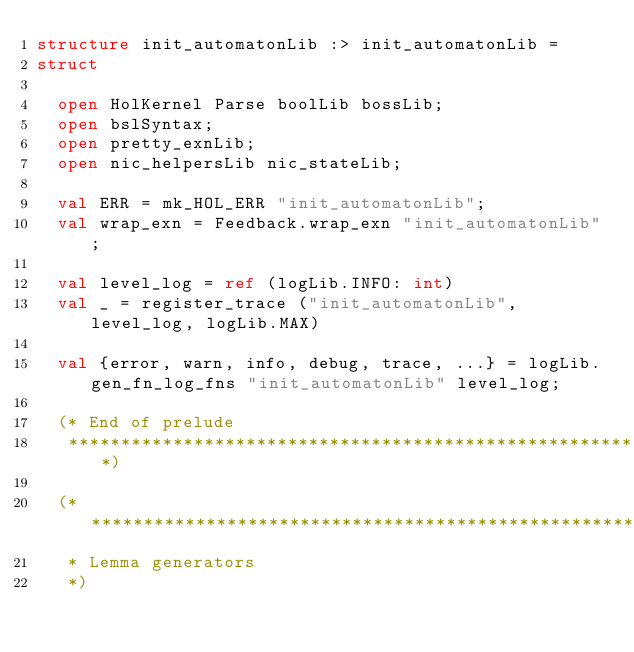Convert code to text. <code><loc_0><loc_0><loc_500><loc_500><_SML_>structure init_automatonLib :> init_automatonLib =
struct

  open HolKernel Parse boolLib bossLib;
  open bslSyntax;
  open pretty_exnLib;
  open nic_helpersLib nic_stateLib;

  val ERR = mk_HOL_ERR "init_automatonLib";
  val wrap_exn = Feedback.wrap_exn "init_automatonLib";

  val level_log = ref (logLib.INFO: int)
  val _ = register_trace ("init_automatonLib", level_log, logLib.MAX)

  val {error, warn, info, debug, trace, ...} = logLib.gen_fn_log_fns "init_automatonLib" level_log;

  (* End of prelude
   ****************************************************************************)

  (*****************************************************************************
   * Lemma generators
   *)
</code> 